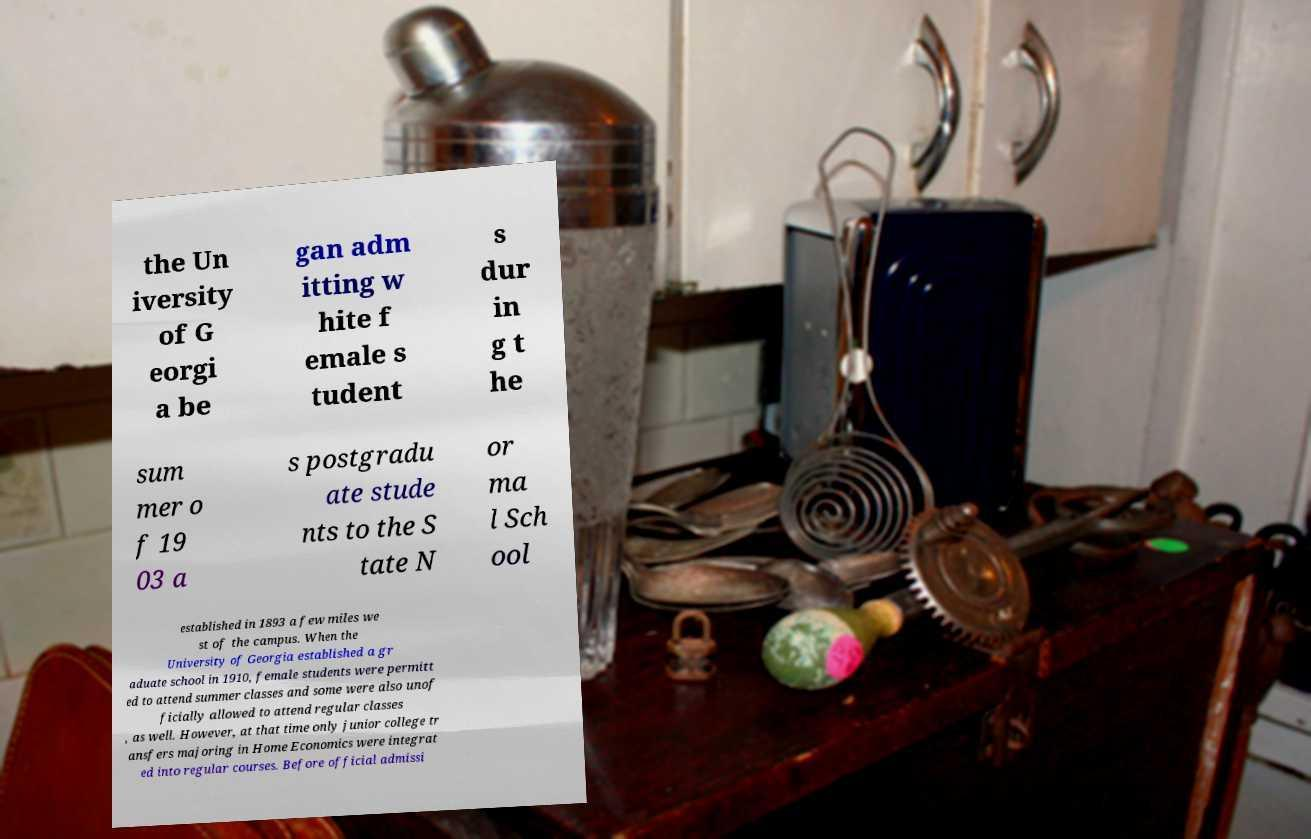Please read and relay the text visible in this image. What does it say? the Un iversity of G eorgi a be gan adm itting w hite f emale s tudent s dur in g t he sum mer o f 19 03 a s postgradu ate stude nts to the S tate N or ma l Sch ool established in 1893 a few miles we st of the campus. When the University of Georgia established a gr aduate school in 1910, female students were permitt ed to attend summer classes and some were also unof ficially allowed to attend regular classes , as well. However, at that time only junior college tr ansfers majoring in Home Economics were integrat ed into regular courses. Before official admissi 